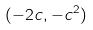<formula> <loc_0><loc_0><loc_500><loc_500>( - 2 c , - c ^ { 2 } )</formula> 